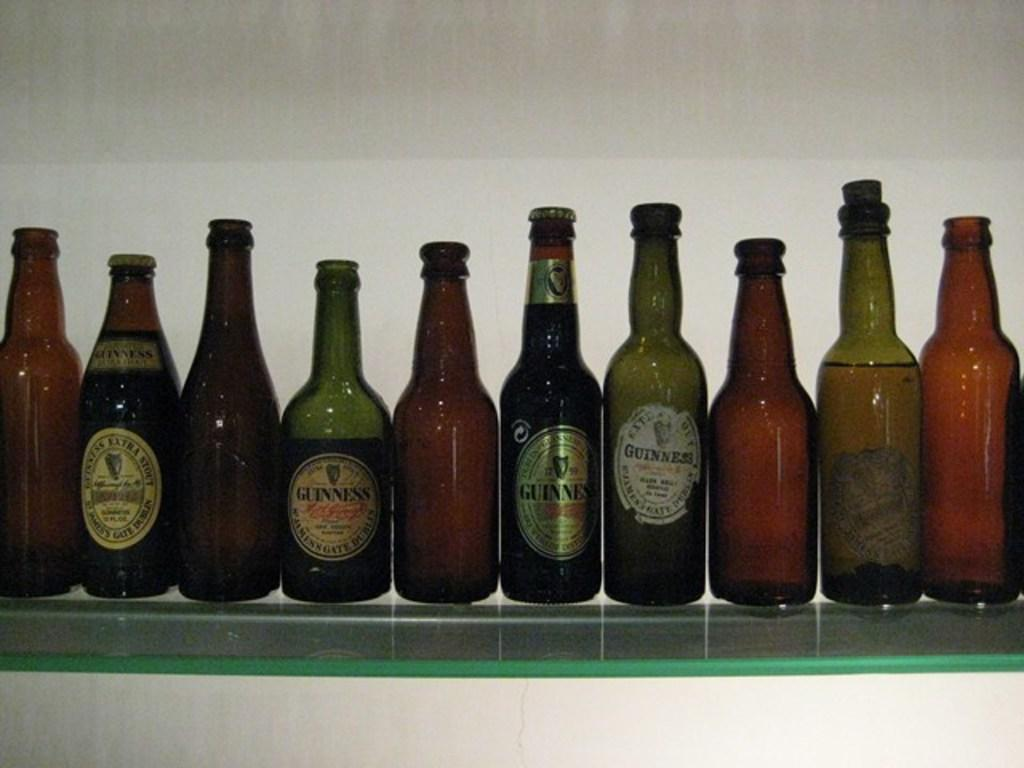What type of bottles are arranged in the image? There are wine bottles in the image. How are the wine bottles arranged? The wine bottles are arranged in a sequence. On what surface are the wine bottles placed? The arrangement is on a glass table. What type of bubble can be seen floating near the wine bottles in the image? There is no bubble present in the image. 